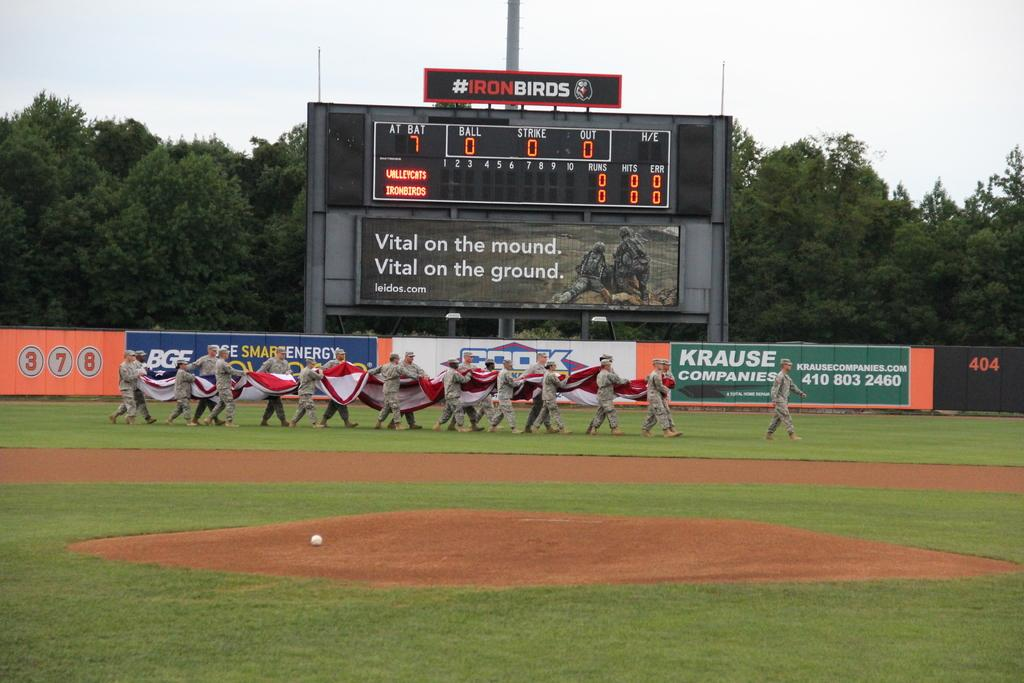<image>
Summarize the visual content of the image. The outfield fence of a baseball stadium features an advertisement for Krause Companies. 